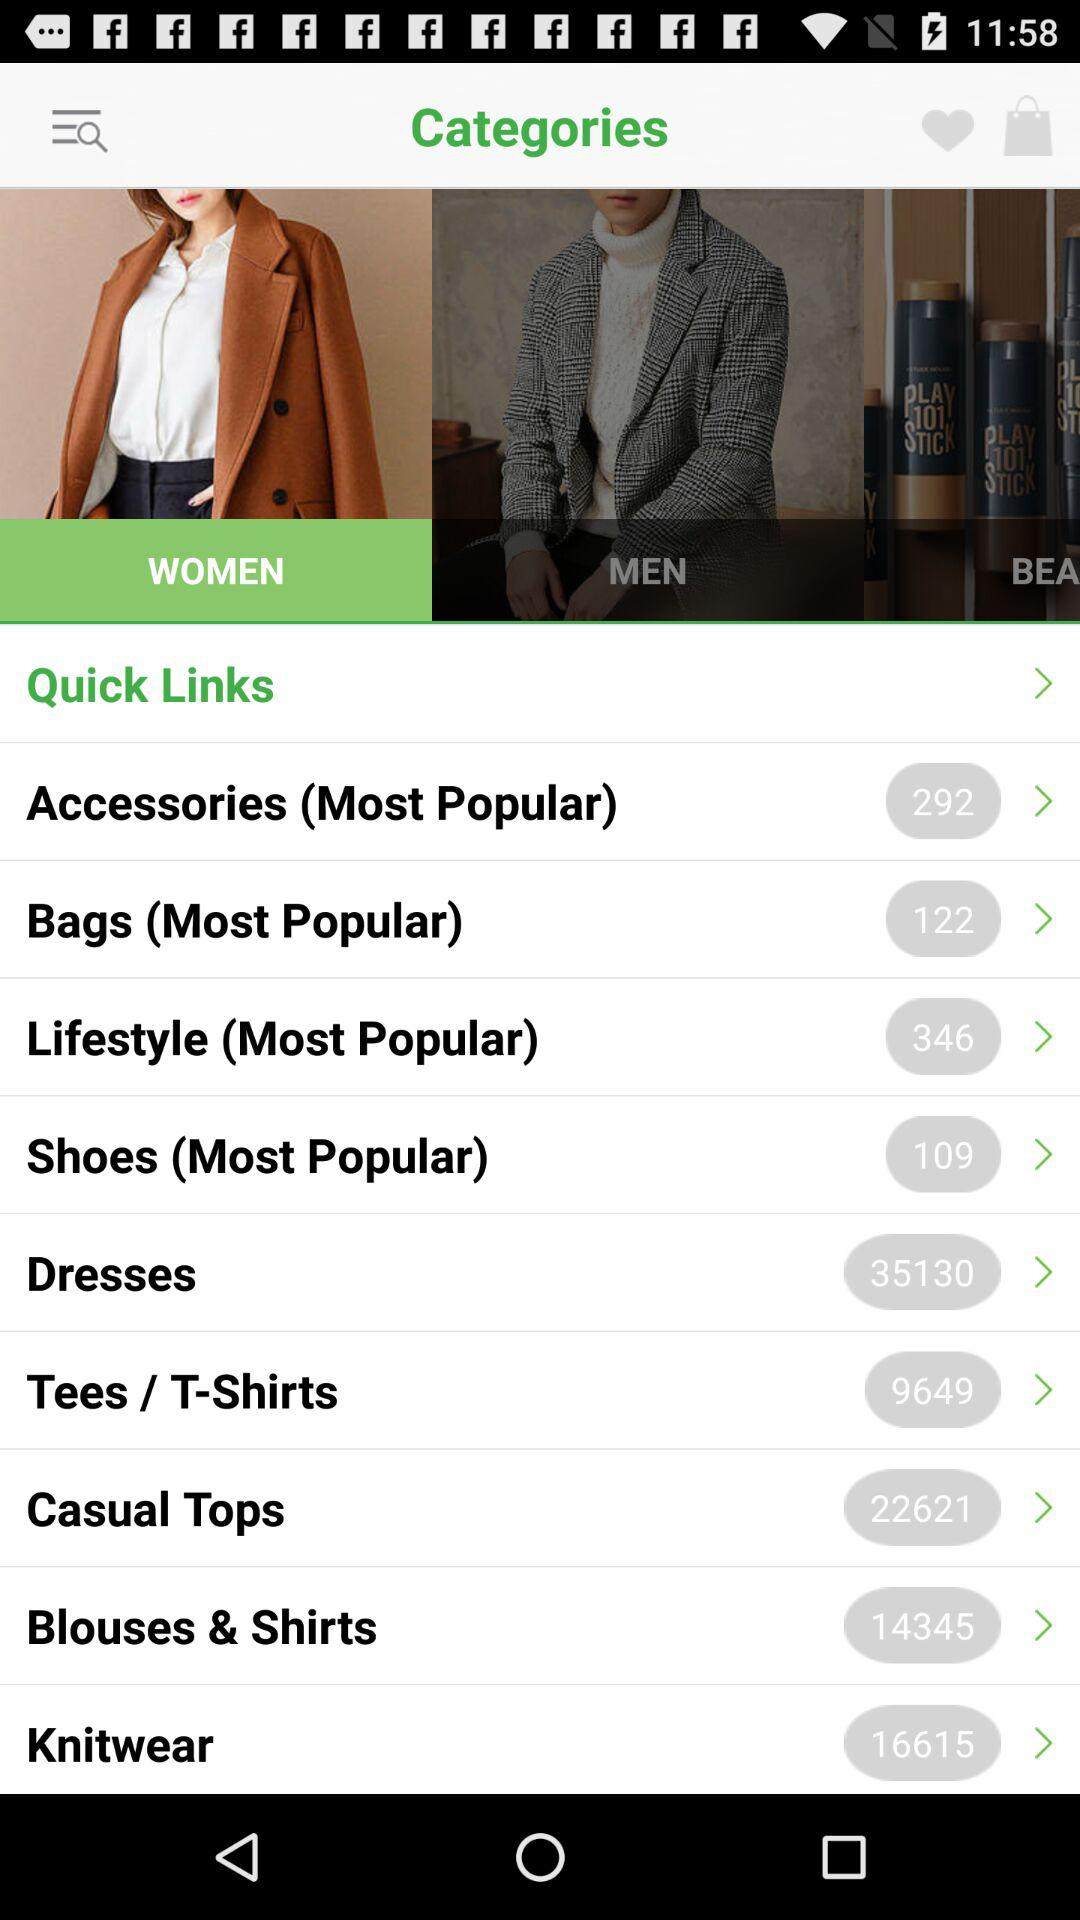Which tab has been chosen? The chosen tab is "WOMEN". 